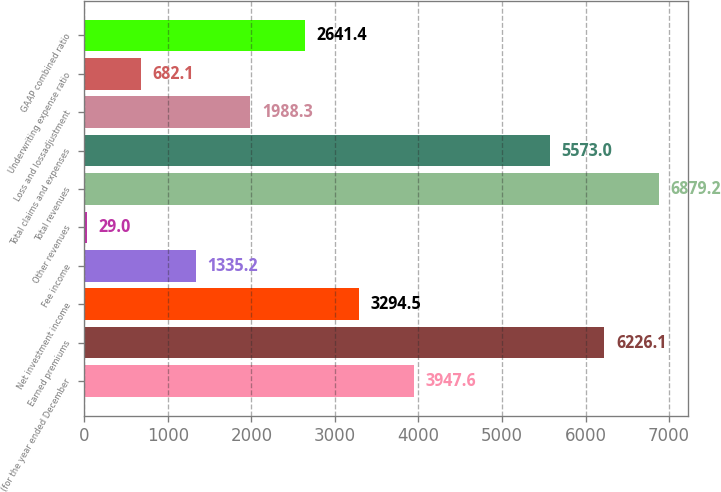Convert chart to OTSL. <chart><loc_0><loc_0><loc_500><loc_500><bar_chart><fcel>(for the year ended December<fcel>Earned premiums<fcel>Net investment income<fcel>Fee income<fcel>Other revenues<fcel>Total revenues<fcel>Total claims and expenses<fcel>Loss and lossadjustment<fcel>Underwriting expense ratio<fcel>GAAP combined ratio<nl><fcel>3947.6<fcel>6226.1<fcel>3294.5<fcel>1335.2<fcel>29<fcel>6879.2<fcel>5573<fcel>1988.3<fcel>682.1<fcel>2641.4<nl></chart> 